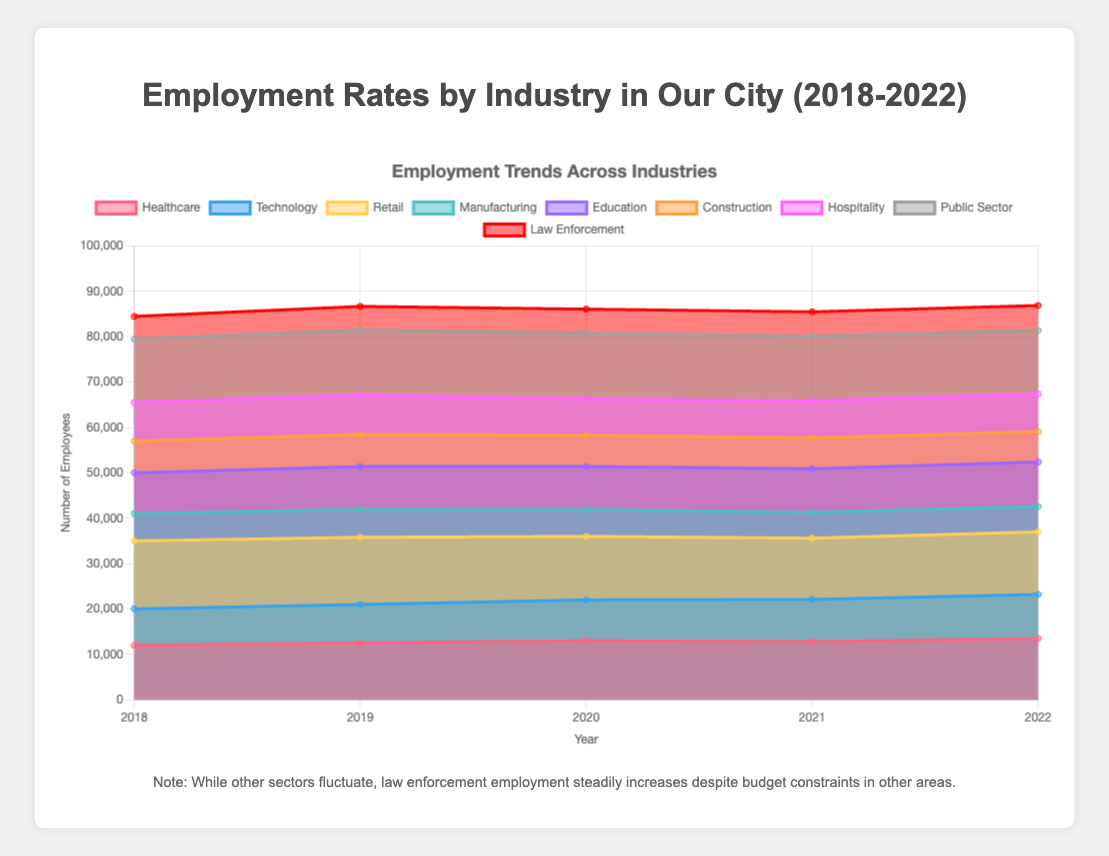What's the overall trend in employment in the Healthcare industry from 2018 to 2022? To determine the trend, observe the data points for Healthcare: 12000, 12500, 13000, 12800, 13500. The numbers generally increase over the years, with a slight dip in 2021 before increasing again in 2022.
Answer: Increasing How does employment in the Law Enforcement sector compare to the Healthcare sector in 2022? In 2022, the employment numbers are 13500 for Healthcare and 5500 for Law Enforcement. The Healthcare sector has significantly higher employment than Law Enforcement.
Answer: Healthcare > Law Enforcement Which industry had the highest employment in 2018? Look at the 2018 data points. Retail has the highest employment at 15000.
Answer: Retail Between 2018 and 2022, which industry experienced a decline in employment? Examine the data points from 2018 to 2022 for each industry. Manufacturing employment decreased from 6000 to 5600, showing a decline over the years.
Answer: Manufacturing What is the percentage increase in Technology employment from 2018 to 2022? Calculate the percentage change using the formula [(new - old) / old] * 100. For Technology, [(9700 - 8000) / 8000] * 100 = 21.25%.
Answer: 21.25% Compare the trend in employment for Retail and Construction industries from 2018 to 2022. Retail decreased from 15000 to 13800, showing a downward trend. Construction also decreased from 7000 to 6700. Both industries declined, but Retail experienced a larger decrease.
Answer: Both decreased, Retail more Which years did the Public Sector see a fall in employment? Look at the Public Sector data: 14000 (2018), 14300 (2019), 14500 (2020), 14200 (2021), 14000 (2022). The employment fell in 2021 and remained the same in 2022.
Answer: 2021, 2022 How did employment in the Hospitality industry change from 2020 to 2021? Look at the data for Hospitality: 8000 (2020) to 8200 (2021). The employment increased by 200.
Answer: Increased by 200 What were the two industries with the lowest employment in 2019? Examine the 2019 data. Law Enforcement (5200) and Manufacturing (6200) have the lowest employment numbers.
Answer: Law Enforcement, Manufacturing What's the cumulative increase in employment in Education from 2018 to 2022? Add up annual changes: (9400-9000) + (9500-9400) + (9600-9500) + (9800-9600). That's 400 + 100 + 100 + 200 = 800.
Answer: 800 